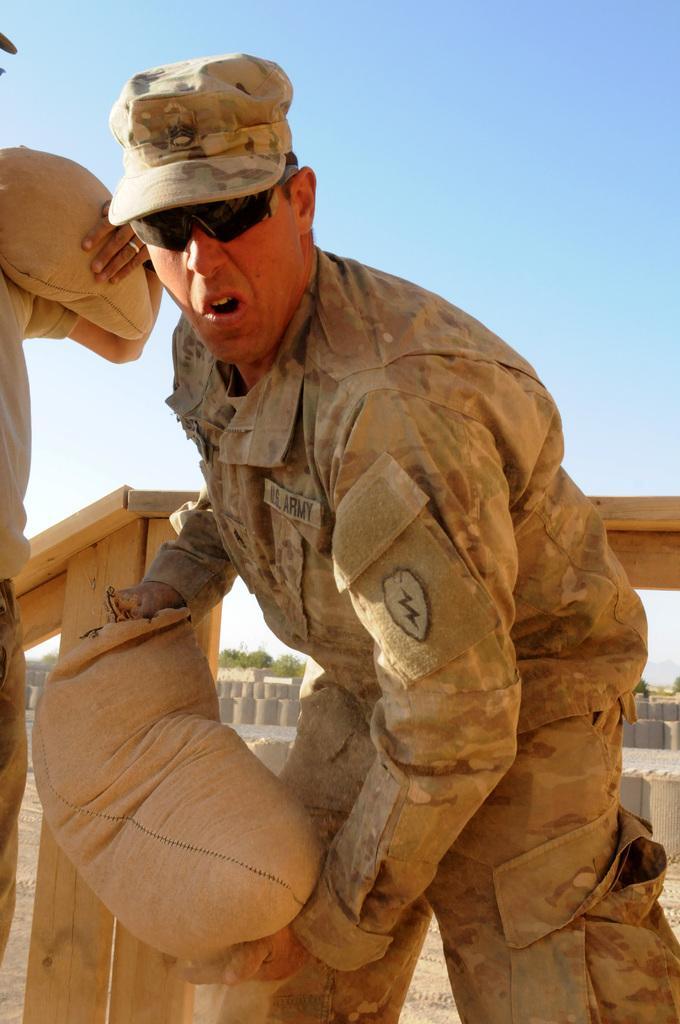Can you describe this image briefly? In this image we can see two persons holding objects. Behind the person we can see a wooden fence and a group of trees. At the top we can see the sky. 